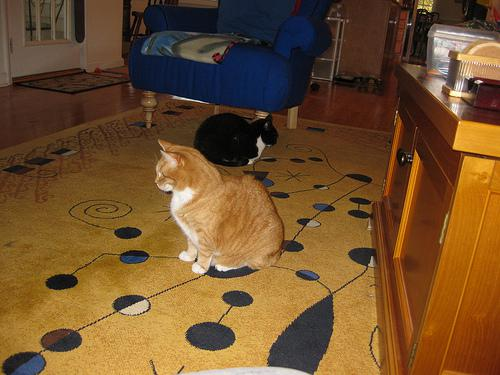Question: how many cats are there?
Choices:
A. One.
B. Three.
C. Four.
D. Two.
Answer with the letter. Answer: D Question: what color is the closest cat?
Choices:
A. Orange and white.
B. Grey.
C. Black.
D. White.
Answer with the letter. Answer: A Question: where is this picture taken?
Choices:
A. In a house.
B. In a living room.
C. In a bedroom.
D. In a hotel.
Answer with the letter. Answer: A Question: what are the cats sitting on?
Choices:
A. A couch.
B. Rug.
C. The floor.
D. A cat bed.
Answer with the letter. Answer: B Question: what color is the farthest cat?
Choices:
A. Black.
B. Black and white.
C. White.
D. Grey.
Answer with the letter. Answer: B 